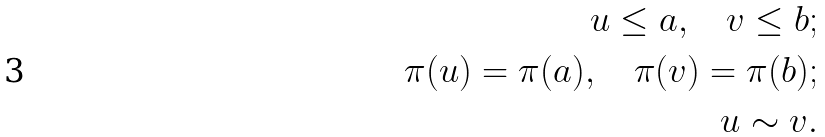Convert formula to latex. <formula><loc_0><loc_0><loc_500><loc_500>u \leq a , \quad v \leq b ; \\ \pi ( u ) = \pi ( a ) , \quad \pi ( v ) = \pi ( b ) ; \\ u \sim v .</formula> 